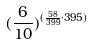Convert formula to latex. <formula><loc_0><loc_0><loc_500><loc_500>( \frac { 6 } { 1 0 } ) ^ { ( \frac { 5 8 } { 3 9 9 } \cdot 3 9 5 ) }</formula> 